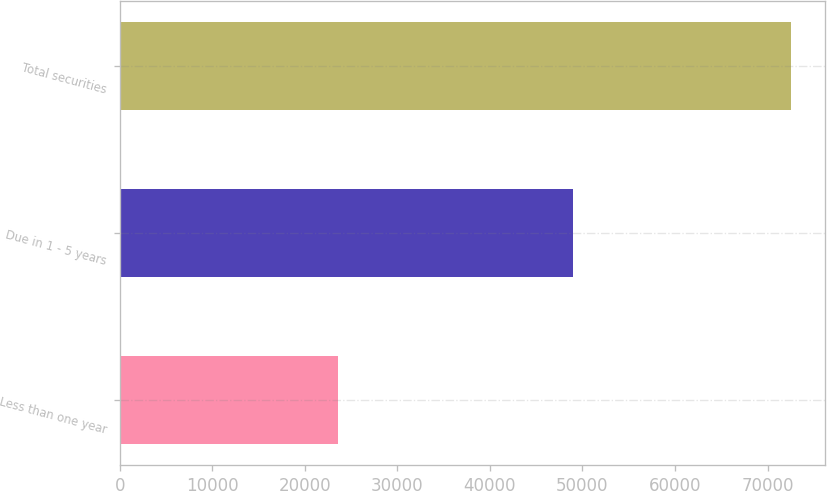Convert chart. <chart><loc_0><loc_0><loc_500><loc_500><bar_chart><fcel>Less than one year<fcel>Due in 1 - 5 years<fcel>Total securities<nl><fcel>23593<fcel>48959<fcel>72552<nl></chart> 